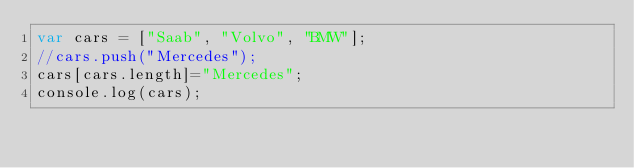Convert code to text. <code><loc_0><loc_0><loc_500><loc_500><_JavaScript_>var cars = ["Saab", "Volvo", "BMW"];
//cars.push("Mercedes");
cars[cars.length]="Mercedes";
console.log(cars);</code> 